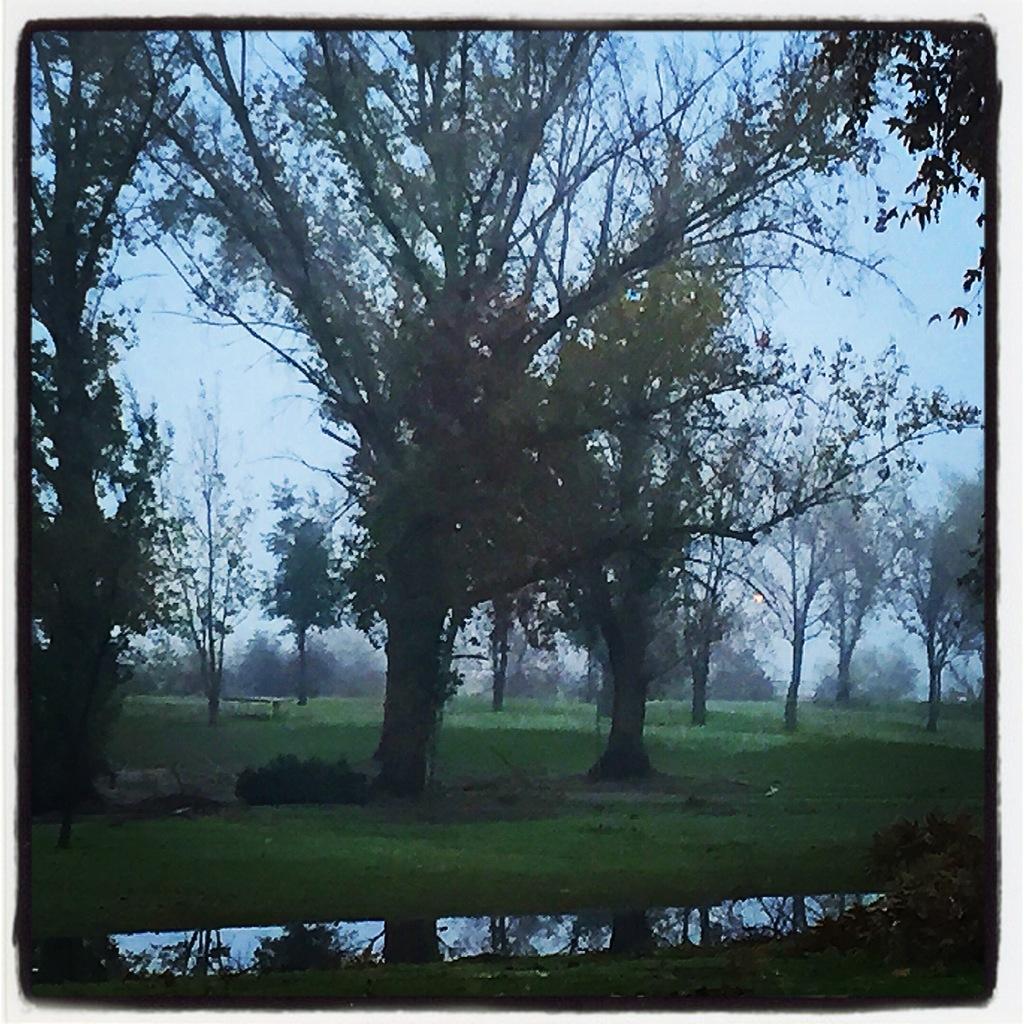In one or two sentences, can you explain what this image depicts? In this image in the middle, there are trees. At the bottom, there are plants, grass, water. At the top there is sky. 